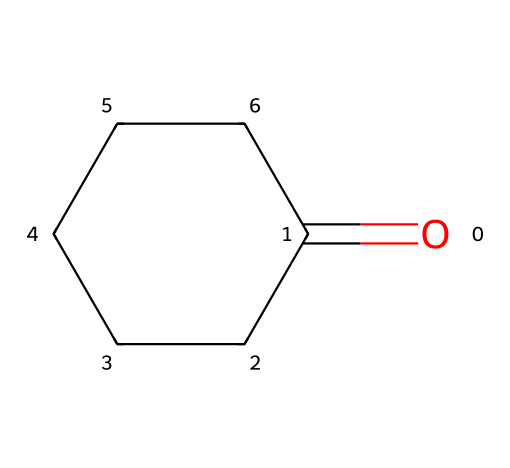What is the molecular formula of cyclohexanone? The chemical structure shows a six-membered carbon ring (C6) with one oxygen atom involved in a carbonyl group. Thus, the formula can be established as C6H10O.
Answer: C6H10O How many carbon atoms are in cyclohexanone? By examining the structure, it's evident that there are six carbon atoms in the ring structure.
Answer: 6 What type of functional group is present in cyclohexanone? The carbonyl group (C=O) is identified in the structure, which classifies this compound as a ketone.
Answer: ketone What is the number of hydrogen atoms in cyclohexanone? Each carbon in the ring can bond with two hydrogen atoms in a saturated structure, totaling twelve hydrogens, but one is replaced by the carbonyl group leading to ten.
Answer: 10 How is cyclohexanone classified based on its structure? The structure consists of a cycloalkane (a ring of carbon atoms) with a carbonyl group, establishing it as a cycloalkanone.
Answer: cycloalkanone What is the total number of bonds (single and double) in cyclohexanone? Counting includes the six single C-C bonds in the ring, two single C-H bonds for each carbon (10 total), and one double C=O bond. Hence, it's 6 + 10 + 1 = 17 bonds total.
Answer: 17 